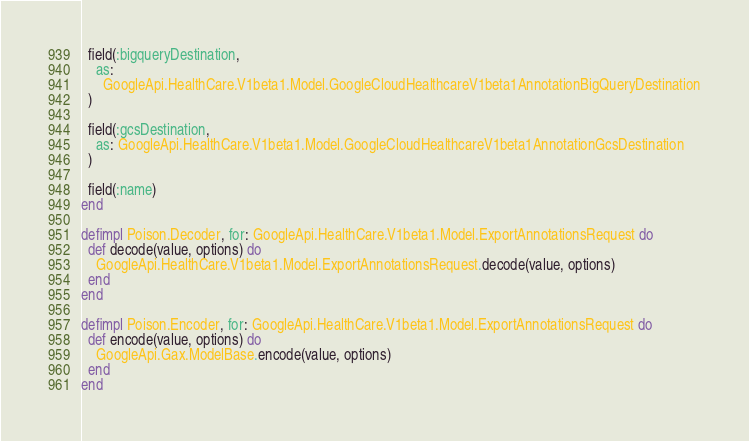<code> <loc_0><loc_0><loc_500><loc_500><_Elixir_>  field(:bigqueryDestination,
    as:
      GoogleApi.HealthCare.V1beta1.Model.GoogleCloudHealthcareV1beta1AnnotationBigQueryDestination
  )

  field(:gcsDestination,
    as: GoogleApi.HealthCare.V1beta1.Model.GoogleCloudHealthcareV1beta1AnnotationGcsDestination
  )

  field(:name)
end

defimpl Poison.Decoder, for: GoogleApi.HealthCare.V1beta1.Model.ExportAnnotationsRequest do
  def decode(value, options) do
    GoogleApi.HealthCare.V1beta1.Model.ExportAnnotationsRequest.decode(value, options)
  end
end

defimpl Poison.Encoder, for: GoogleApi.HealthCare.V1beta1.Model.ExportAnnotationsRequest do
  def encode(value, options) do
    GoogleApi.Gax.ModelBase.encode(value, options)
  end
end
</code> 